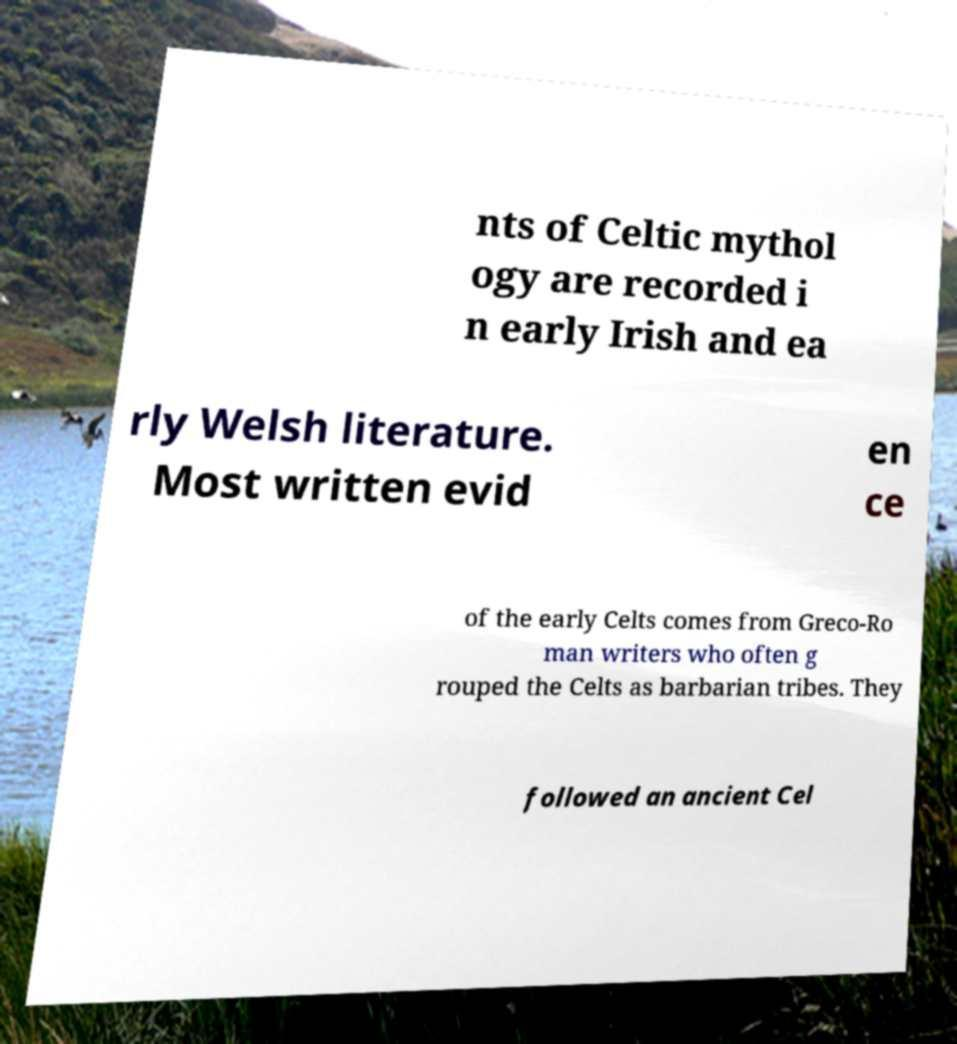There's text embedded in this image that I need extracted. Can you transcribe it verbatim? nts of Celtic mythol ogy are recorded i n early Irish and ea rly Welsh literature. Most written evid en ce of the early Celts comes from Greco-Ro man writers who often g rouped the Celts as barbarian tribes. They followed an ancient Cel 